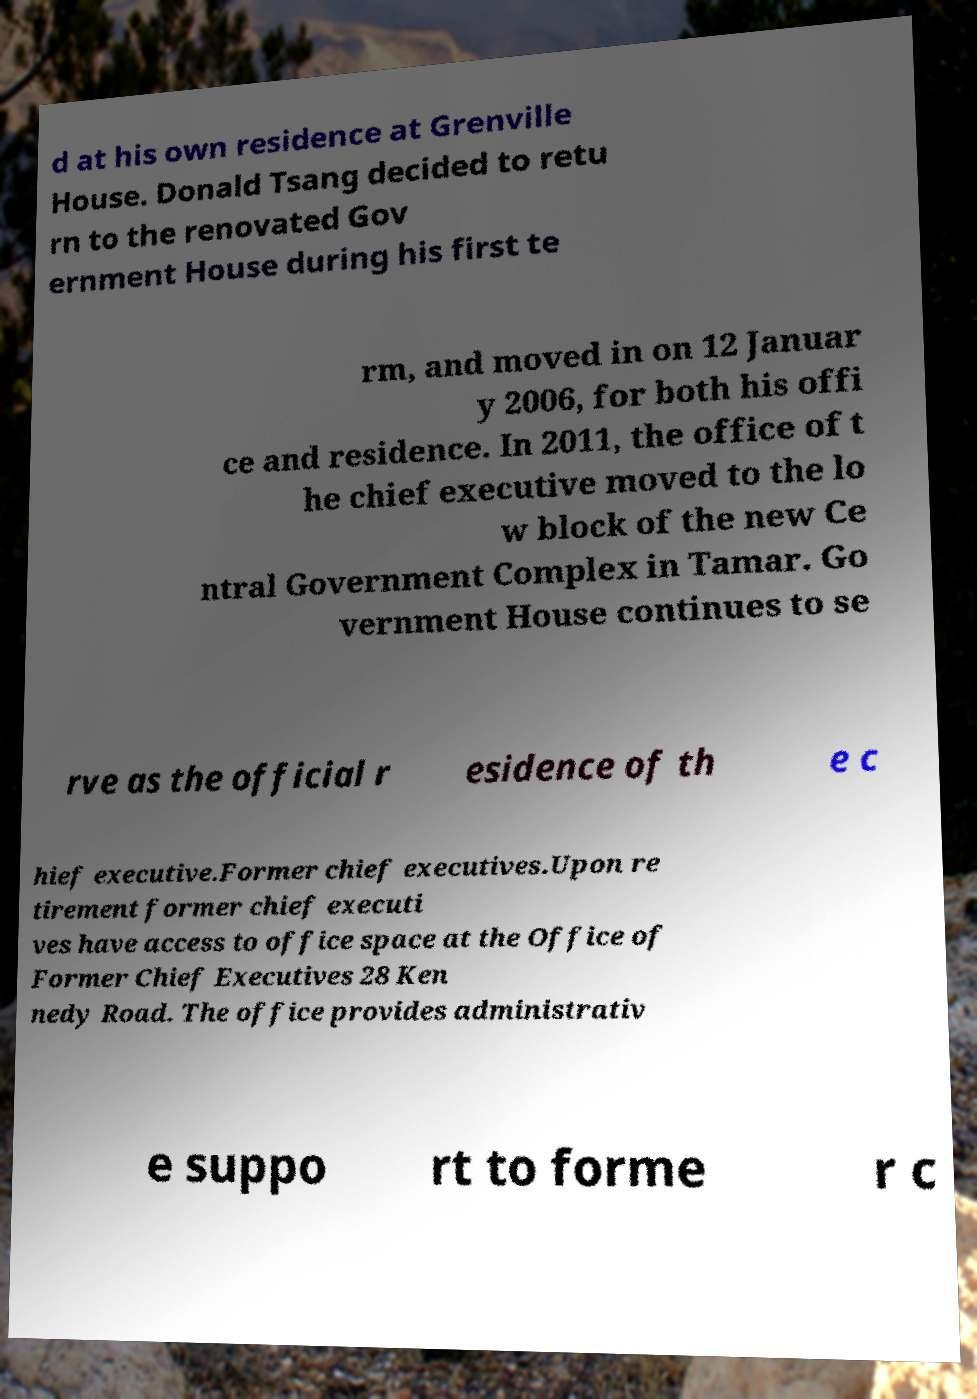Please read and relay the text visible in this image. What does it say? d at his own residence at Grenville House. Donald Tsang decided to retu rn to the renovated Gov ernment House during his first te rm, and moved in on 12 Januar y 2006, for both his offi ce and residence. In 2011, the office of t he chief executive moved to the lo w block of the new Ce ntral Government Complex in Tamar. Go vernment House continues to se rve as the official r esidence of th e c hief executive.Former chief executives.Upon re tirement former chief executi ves have access to office space at the Office of Former Chief Executives 28 Ken nedy Road. The office provides administrativ e suppo rt to forme r c 